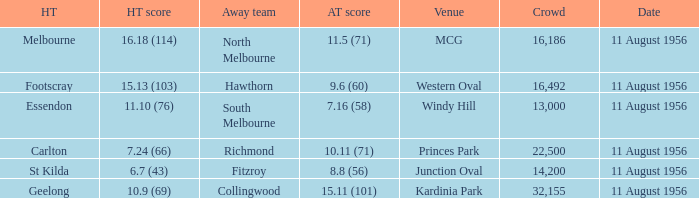What home team played at western oval? Footscray. 